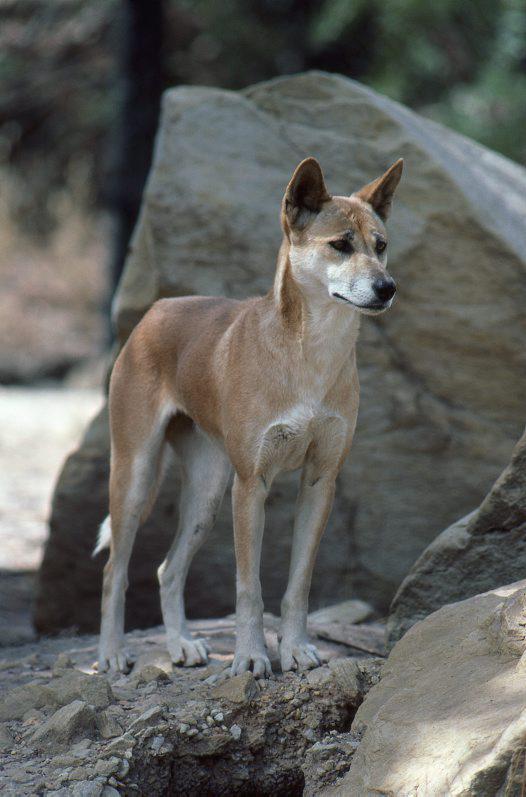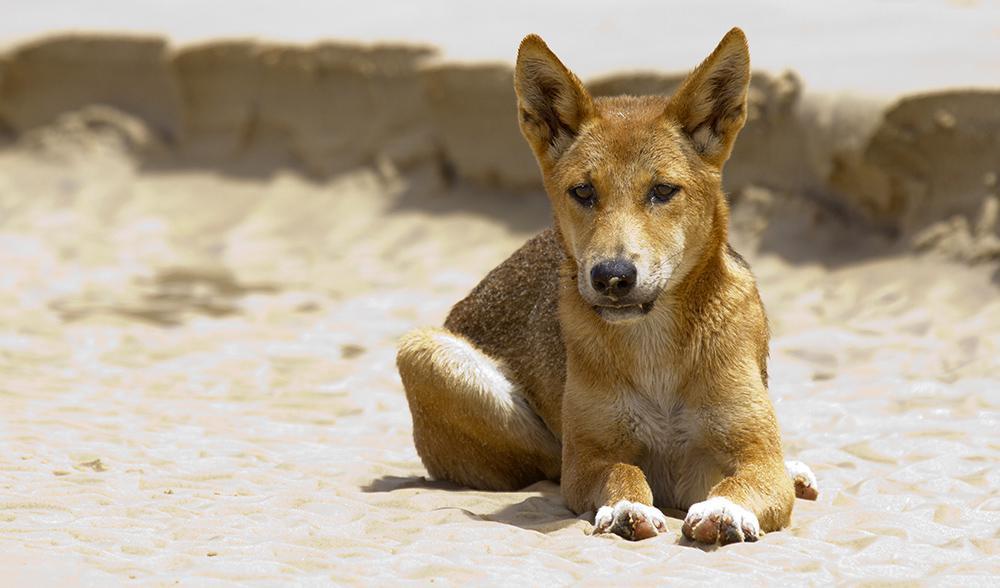The first image is the image on the left, the second image is the image on the right. Evaluate the accuracy of this statement regarding the images: "The dog in the right image is on a grassy surface.". Is it true? Answer yes or no. No. 